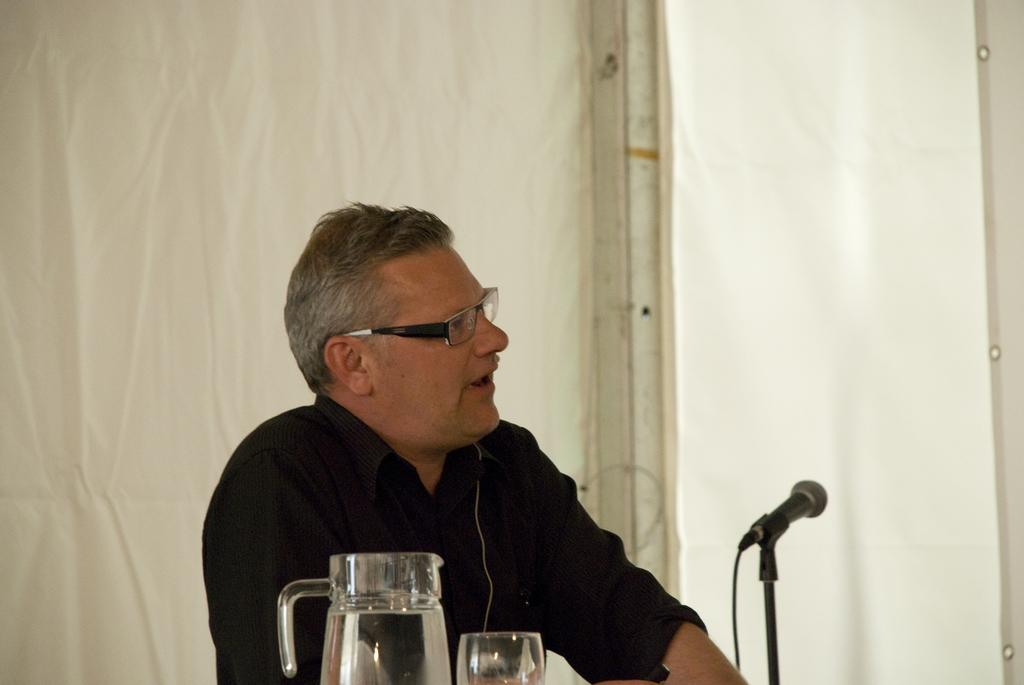What can be seen in the image? There is a person in the image. Can you describe the person's appearance? The person is wearing a shirt and spectacles. What objects are at the bottom of the image? There is a microphone stand, a glass, and a jar at the bottom of the image. What is visible in the background of the image? There is a curtain in the background of the image. What type of celery is being used as a prop in the image? There is no celery present in the image. How many attempts does the person make to hit the volleyball in the image? There is no volleyball present in the image, so it's not possible to determine the number of attempts. 